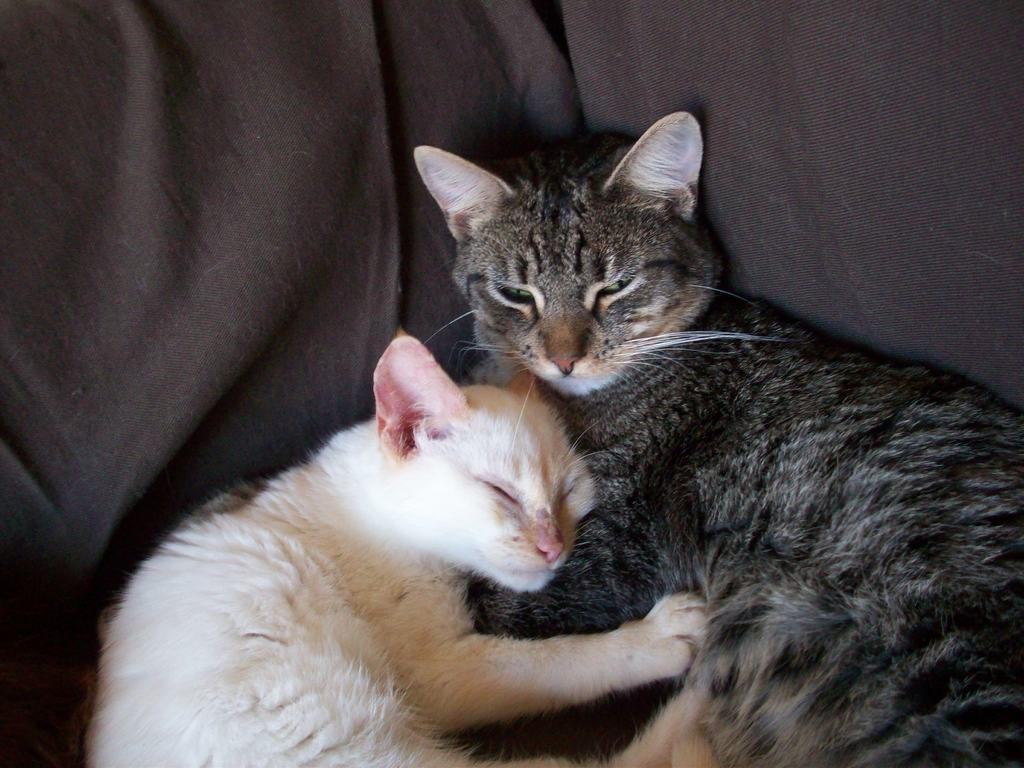How many cats are in the image? There are two cats in the image. Where are the cats located in the image? The cats are on a couch. What type of beginner's lunch can be seen in the image? There is no lunch present in the image, and the cats are not beginners. 